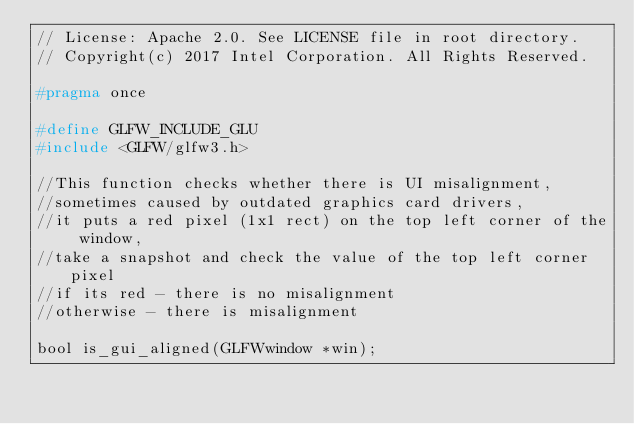<code> <loc_0><loc_0><loc_500><loc_500><_C_>// License: Apache 2.0. See LICENSE file in root directory.
// Copyright(c) 2017 Intel Corporation. All Rights Reserved.

#pragma once

#define GLFW_INCLUDE_GLU
#include <GLFW/glfw3.h>

//This function checks whether there is UI misalignment,
//sometimes caused by outdated graphics card drivers,
//it puts a red pixel (1x1 rect) on the top left corner of the window,
//take a snapshot and check the value of the top left corner pixel
//if its red - there is no misalignment
//otherwise - there is misalignment

bool is_gui_aligned(GLFWwindow *win);
</code> 